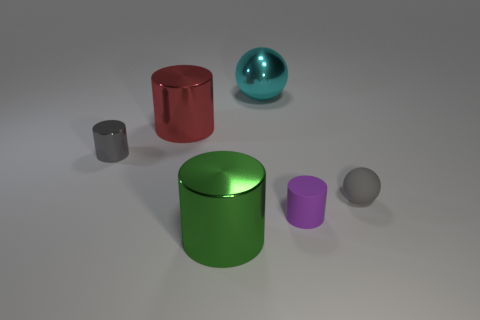Subtract all large green cylinders. How many cylinders are left? 3 Add 3 blue metal cylinders. How many objects exist? 9 Subtract all cylinders. How many objects are left? 2 Subtract all gray spheres. How many spheres are left? 1 Subtract 1 spheres. How many spheres are left? 1 Subtract all purple cubes. How many gray spheres are left? 1 Subtract all blue rubber things. Subtract all gray balls. How many objects are left? 5 Add 5 small objects. How many small objects are left? 8 Add 6 large cylinders. How many large cylinders exist? 8 Subtract 0 red spheres. How many objects are left? 6 